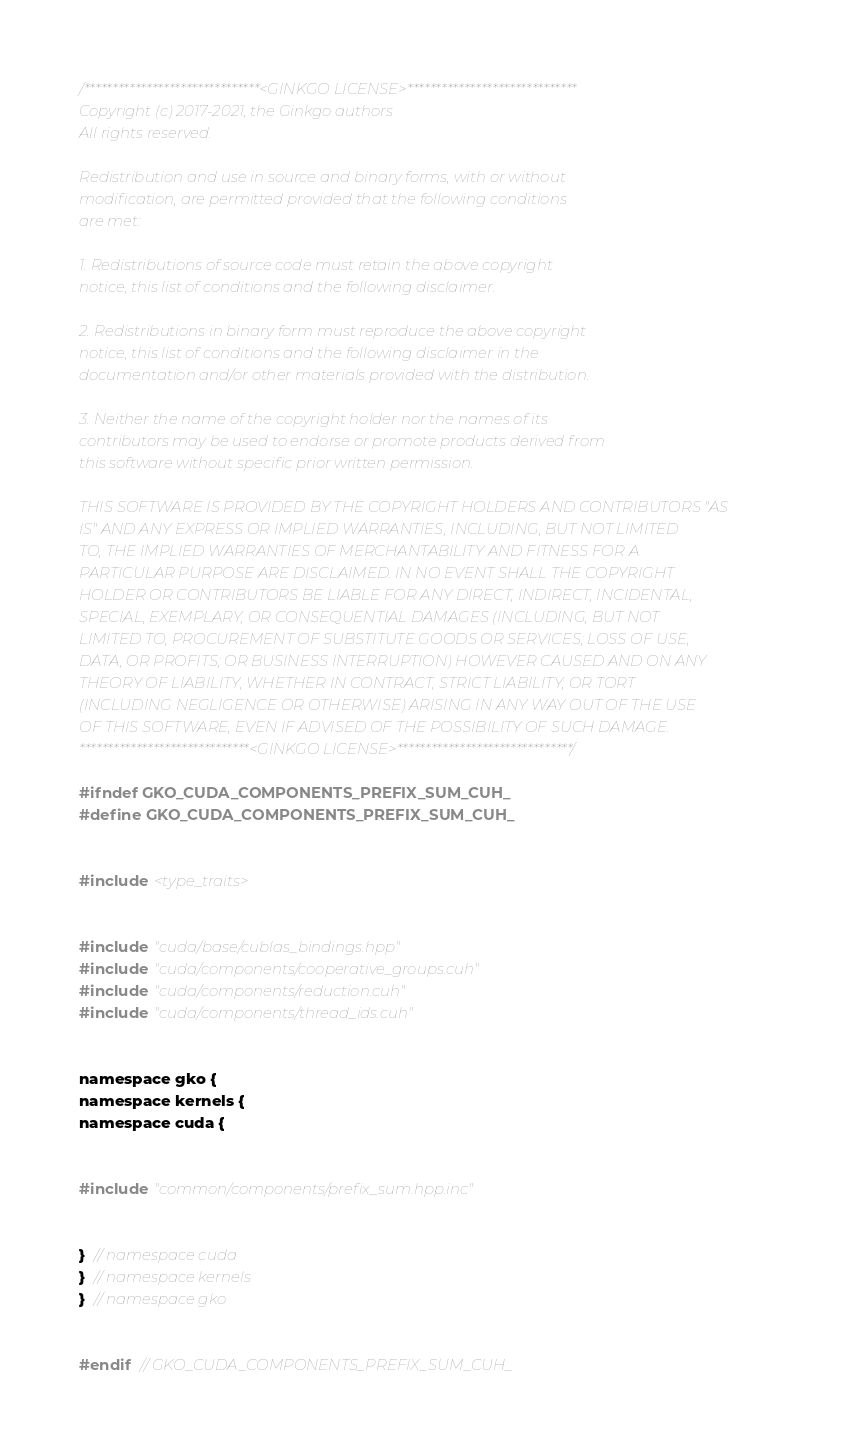Convert code to text. <code><loc_0><loc_0><loc_500><loc_500><_Cuda_>/*******************************<GINKGO LICENSE>******************************
Copyright (c) 2017-2021, the Ginkgo authors
All rights reserved.

Redistribution and use in source and binary forms, with or without
modification, are permitted provided that the following conditions
are met:

1. Redistributions of source code must retain the above copyright
notice, this list of conditions and the following disclaimer.

2. Redistributions in binary form must reproduce the above copyright
notice, this list of conditions and the following disclaimer in the
documentation and/or other materials provided with the distribution.

3. Neither the name of the copyright holder nor the names of its
contributors may be used to endorse or promote products derived from
this software without specific prior written permission.

THIS SOFTWARE IS PROVIDED BY THE COPYRIGHT HOLDERS AND CONTRIBUTORS "AS
IS" AND ANY EXPRESS OR IMPLIED WARRANTIES, INCLUDING, BUT NOT LIMITED
TO, THE IMPLIED WARRANTIES OF MERCHANTABILITY AND FITNESS FOR A
PARTICULAR PURPOSE ARE DISCLAIMED. IN NO EVENT SHALL THE COPYRIGHT
HOLDER OR CONTRIBUTORS BE LIABLE FOR ANY DIRECT, INDIRECT, INCIDENTAL,
SPECIAL, EXEMPLARY, OR CONSEQUENTIAL DAMAGES (INCLUDING, BUT NOT
LIMITED TO, PROCUREMENT OF SUBSTITUTE GOODS OR SERVICES; LOSS OF USE,
DATA, OR PROFITS; OR BUSINESS INTERRUPTION) HOWEVER CAUSED AND ON ANY
THEORY OF LIABILITY, WHETHER IN CONTRACT, STRICT LIABILITY, OR TORT
(INCLUDING NEGLIGENCE OR OTHERWISE) ARISING IN ANY WAY OUT OF THE USE
OF THIS SOFTWARE, EVEN IF ADVISED OF THE POSSIBILITY OF SUCH DAMAGE.
******************************<GINKGO LICENSE>*******************************/

#ifndef GKO_CUDA_COMPONENTS_PREFIX_SUM_CUH_
#define GKO_CUDA_COMPONENTS_PREFIX_SUM_CUH_


#include <type_traits>


#include "cuda/base/cublas_bindings.hpp"
#include "cuda/components/cooperative_groups.cuh"
#include "cuda/components/reduction.cuh"
#include "cuda/components/thread_ids.cuh"


namespace gko {
namespace kernels {
namespace cuda {


#include "common/components/prefix_sum.hpp.inc"


}  // namespace cuda
}  // namespace kernels
}  // namespace gko


#endif  // GKO_CUDA_COMPONENTS_PREFIX_SUM_CUH_
</code> 